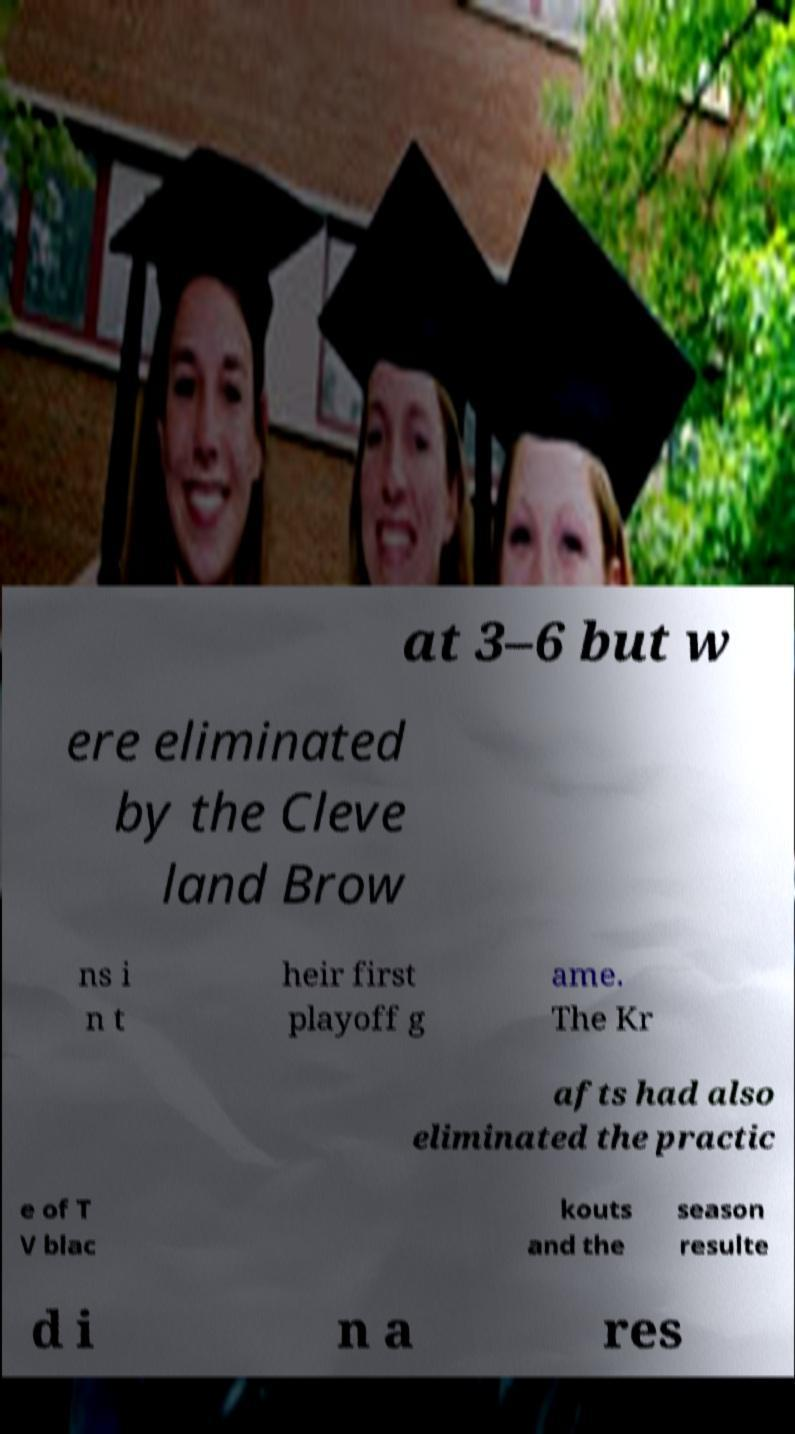Please identify and transcribe the text found in this image. at 3–6 but w ere eliminated by the Cleve land Brow ns i n t heir first playoff g ame. The Kr afts had also eliminated the practic e of T V blac kouts and the season resulte d i n a res 